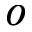<formula> <loc_0><loc_0><loc_500><loc_500>o</formula> 